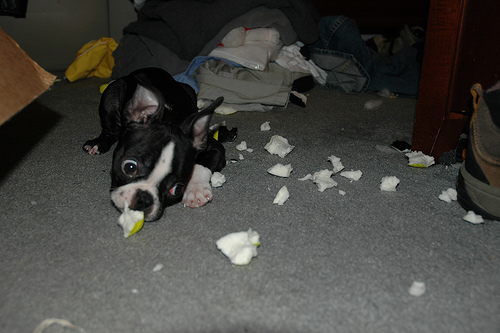<image>
Is the dog next to the piece? Yes. The dog is positioned adjacent to the piece, located nearby in the same general area. 